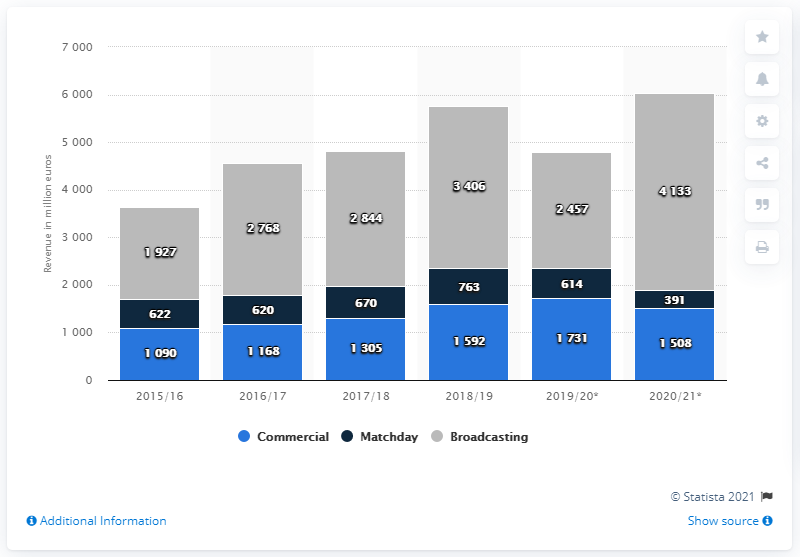Draw attention to some important aspects in this diagram. The projected earnings of the Premier League clubs for the 2020/21 season are estimated to be 391 million pounds. 